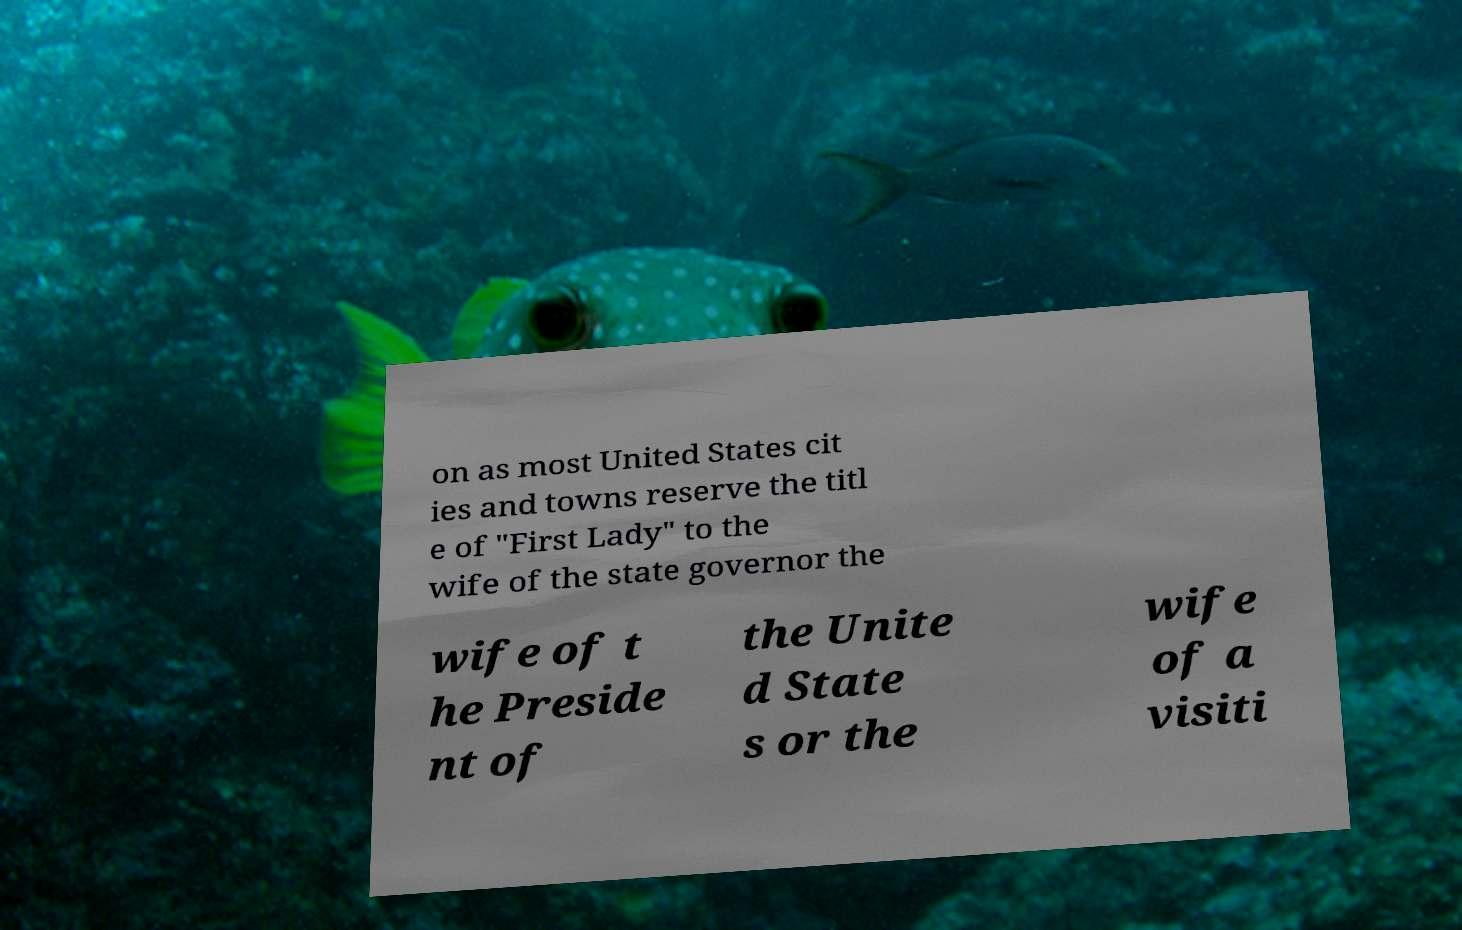Please read and relay the text visible in this image. What does it say? on as most United States cit ies and towns reserve the titl e of "First Lady" to the wife of the state governor the wife of t he Preside nt of the Unite d State s or the wife of a visiti 